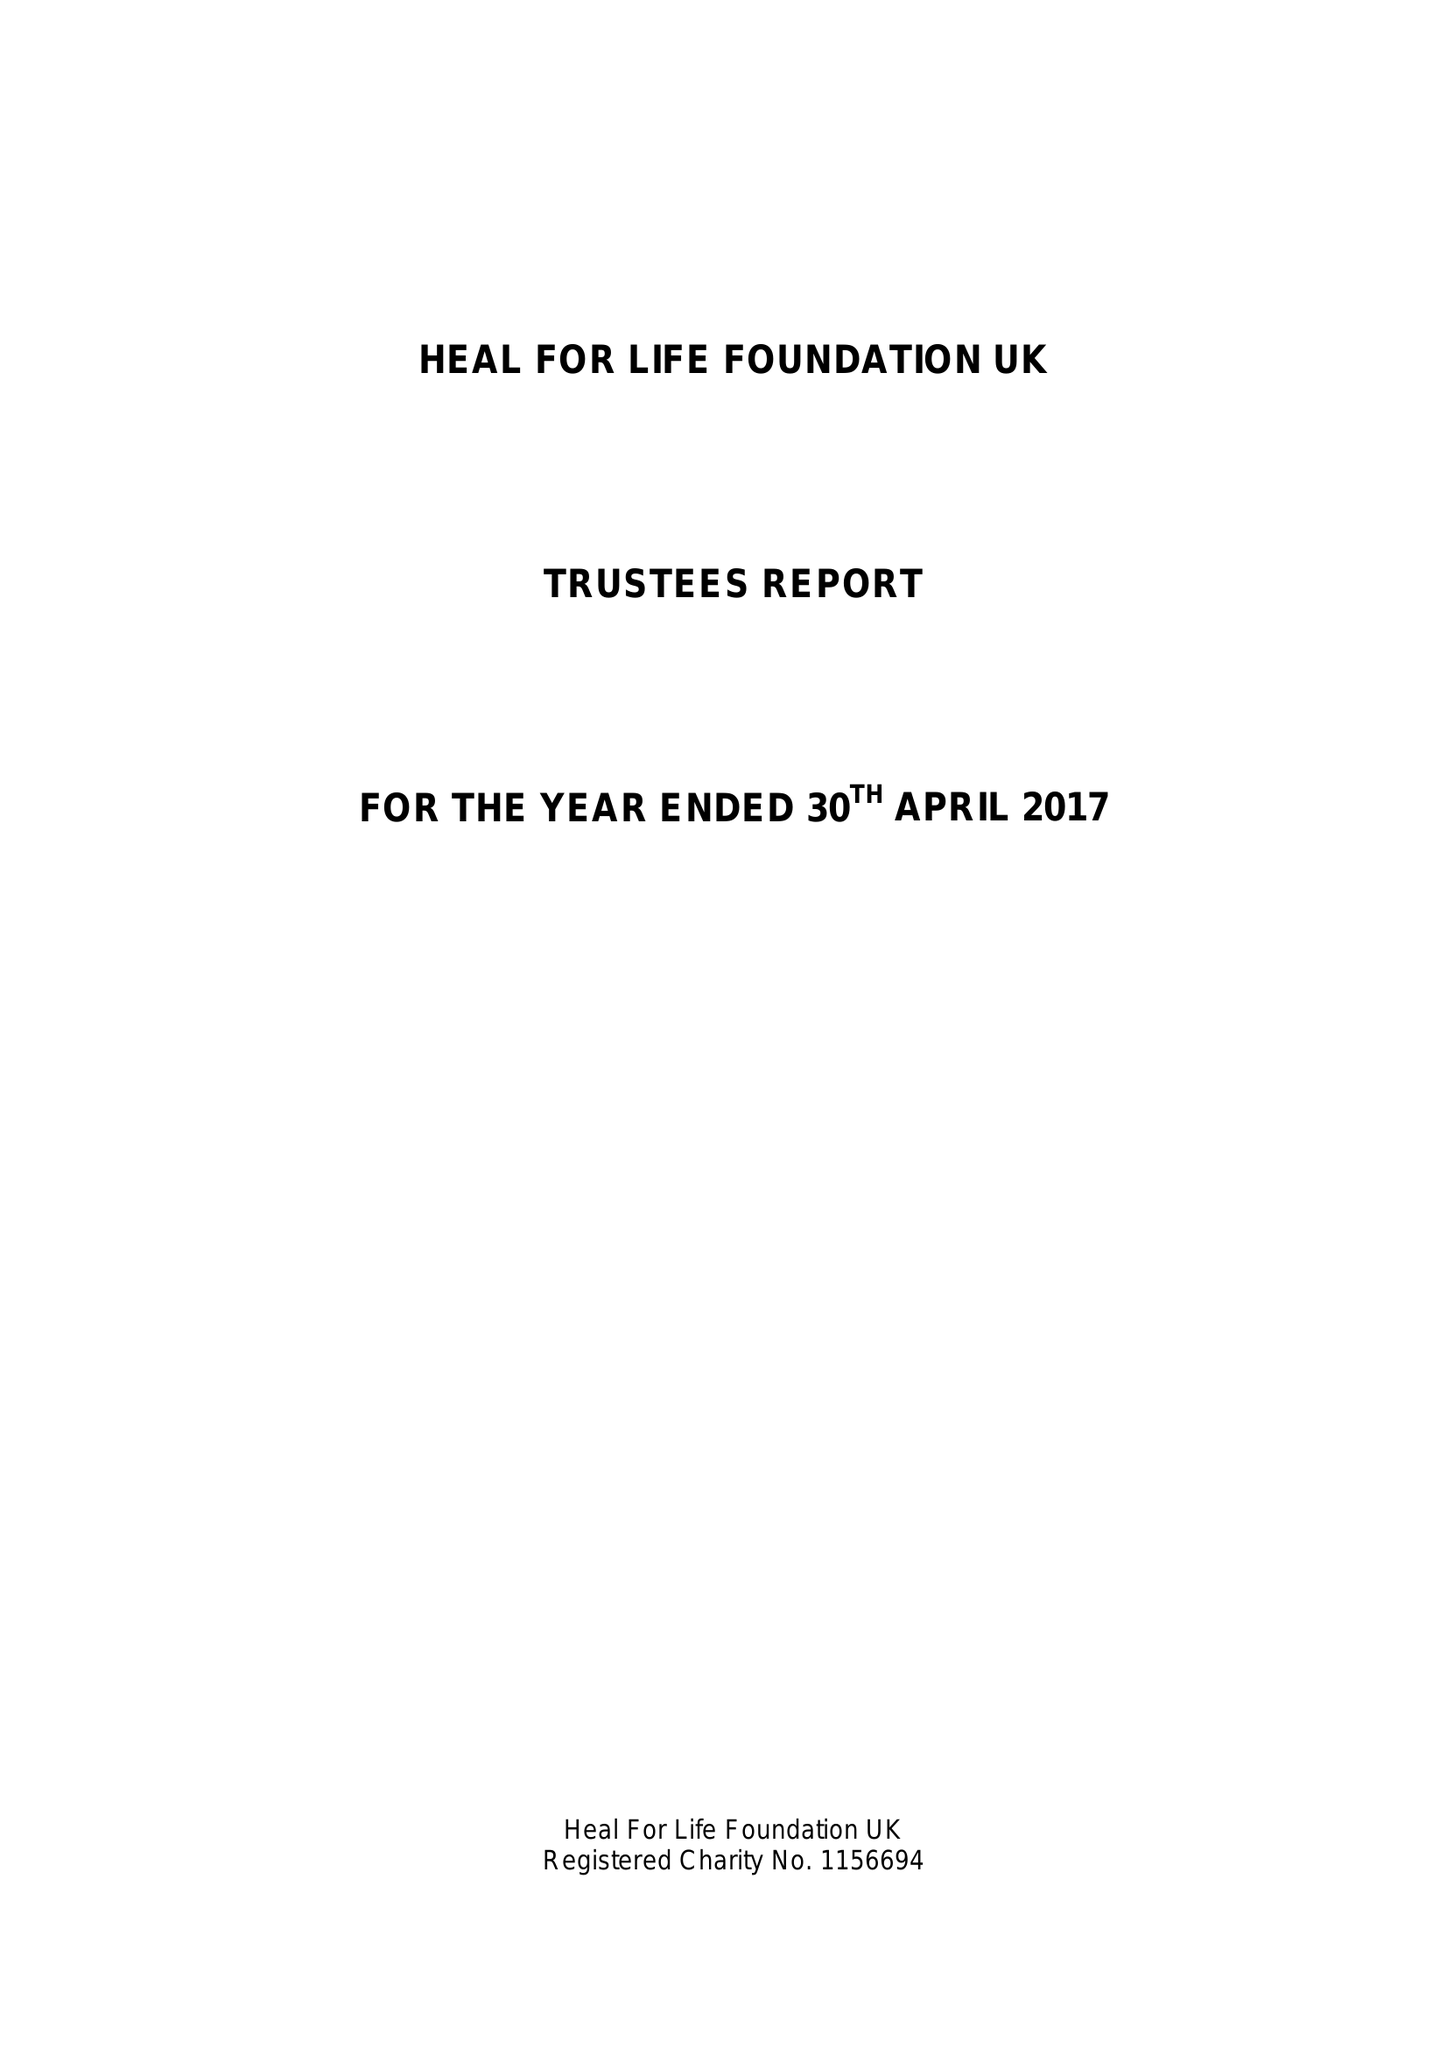What is the value for the charity_name?
Answer the question using a single word or phrase. Heal For Life Foundation Uk 